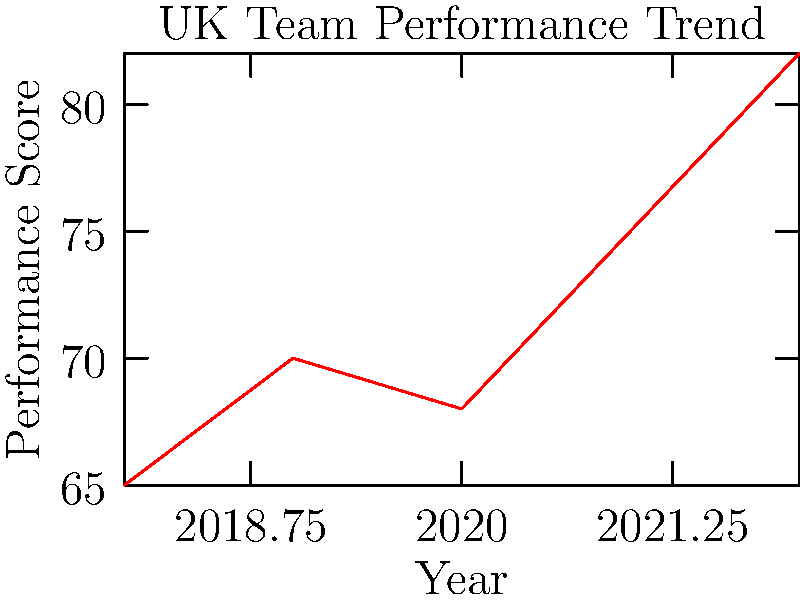Based on the line graph showing the UK team's performance trends over the past five years, what can you conclude about their progress leading up to the most recent year? To interpret the UK team's performance trend, let's analyze the graph step-by-step:

1. First, we observe the overall trend from 2018 to 2022.
2. In 2018, the team's performance score was 65.
3. There was an increase to 70 in 2019.
4. A slight dip occurred in 2020, bringing the score to 68.
5. From 2020 onwards, we see a consistent upward trend:
   - 2020: 68
   - 2021: 75 (a significant jump)
   - 2022: 82 (another substantial increase)
6. The change from 2021 to 2022 shows the steepest increase in the entire five-year period.
7. Comparing the starting point (65 in 2018) to the endpoint (82 in 2022), we see a marked overall improvement.

Given this analysis, we can conclude that the UK team has shown significant improvement, especially in the last two years, with their best performance recorded in the most recent year (2022).
Answer: Significant improvement, peaking in 2022 